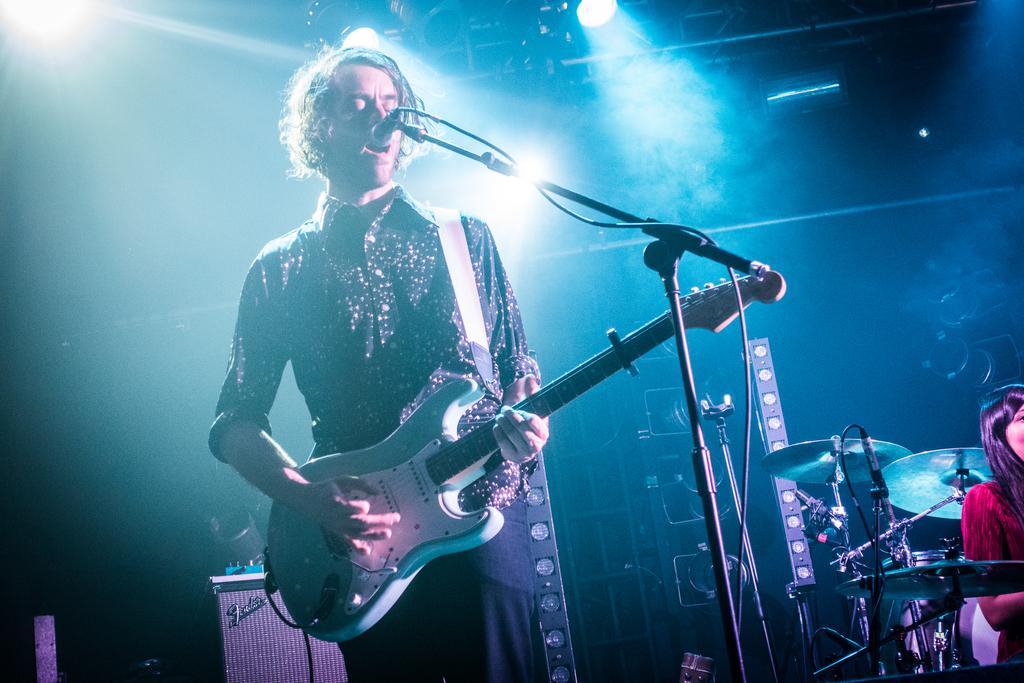Describe this image in one or two sentences. In this image, there is a person wearing clothes and playing a guitar. There is a mic in front of this person. There is a person and and some musical instruments in the bottom right of the picture. There are two lights at the top of the image. 